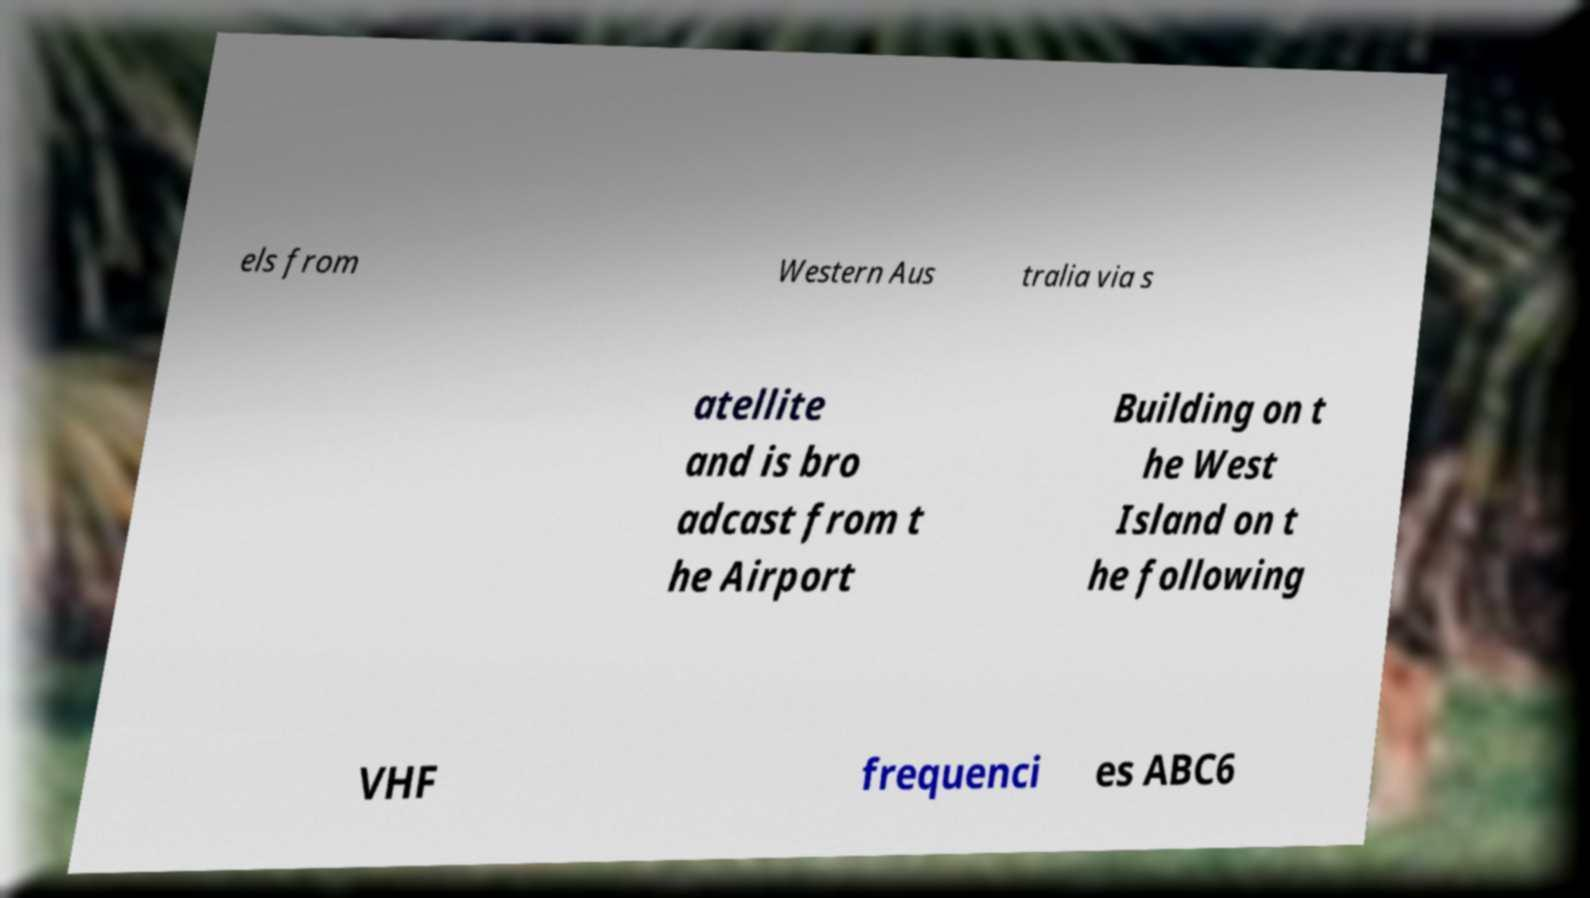Could you extract and type out the text from this image? els from Western Aus tralia via s atellite and is bro adcast from t he Airport Building on t he West Island on t he following VHF frequenci es ABC6 